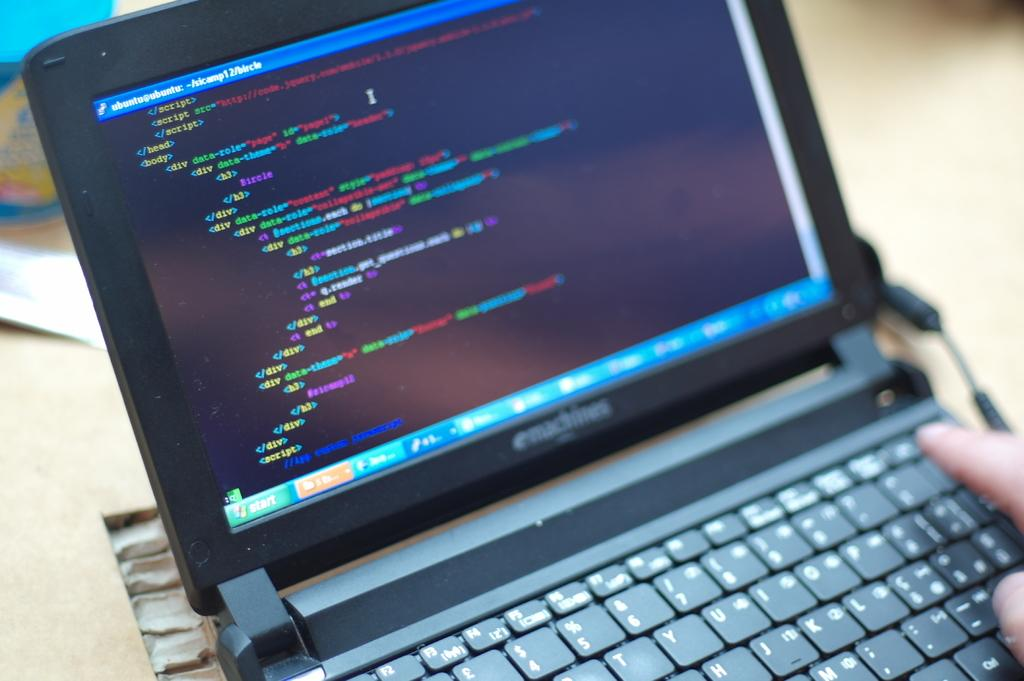<image>
Write a terse but informative summary of the picture. ubuntu@ubuntu is the header of the screen shown on this laptop. 